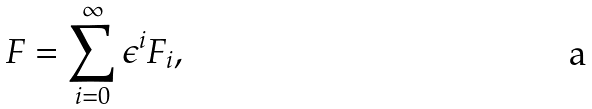Convert formula to latex. <formula><loc_0><loc_0><loc_500><loc_500>F = \sum _ { i = 0 } ^ { \infty } \epsilon ^ { i } F _ { i } ,</formula> 